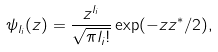Convert formula to latex. <formula><loc_0><loc_0><loc_500><loc_500>\psi _ { l _ { i } } ( z ) = \frac { z ^ { l _ { i } } } { \sqrt { \pi { l _ { i } } ! } } \exp ( - z z ^ { * } / 2 ) ,</formula> 